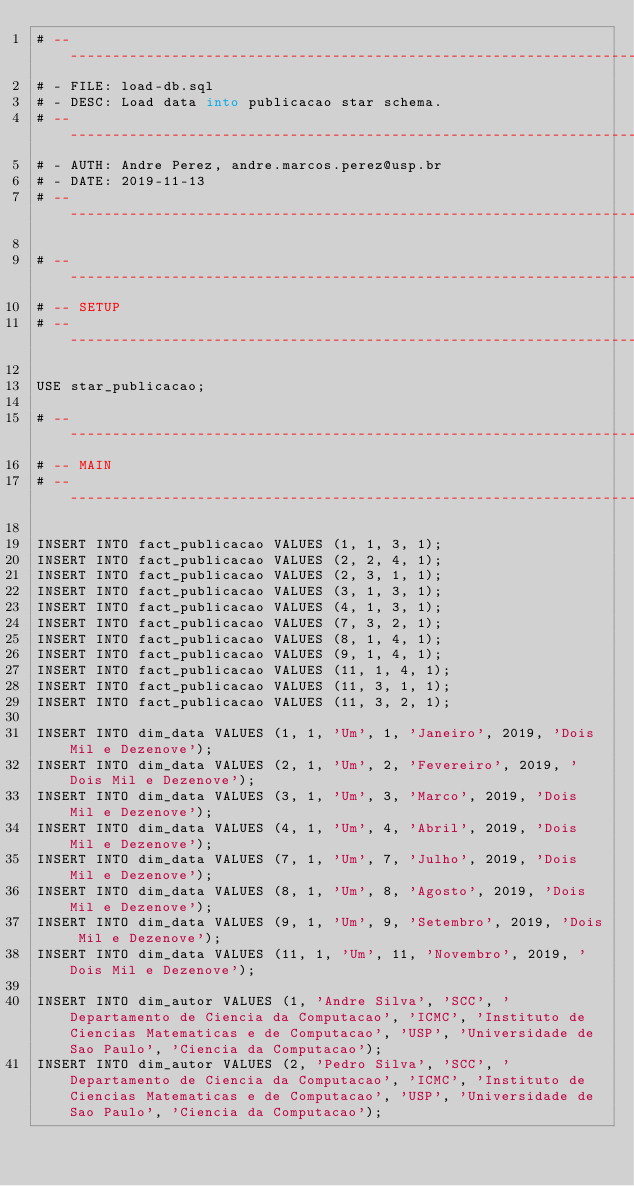Convert code to text. <code><loc_0><loc_0><loc_500><loc_500><_SQL_># ----------------------------------------------------------------------------
# - FILE: load-db.sql
# - DESC: Load data into publicacao star schema.
# ----------------------------------------------------------------------------
# - AUTH: Andre Perez, andre.marcos.perez@usp.br
# - DATE: 2019-11-13
# ----------------------------------------------------------------------------

# ----------------------------------------------------------------------------
# -- SETUP
# ----------------------------------------------------------------------------

USE star_publicacao;

# ----------------------------------------------------------------------------
# -- MAIN
# ----------------------------------------------------------------------------

INSERT INTO fact_publicacao VALUES (1, 1, 3, 1);
INSERT INTO fact_publicacao VALUES (2, 2, 4, 1);
INSERT INTO fact_publicacao VALUES (2, 3, 1, 1);
INSERT INTO fact_publicacao VALUES (3, 1, 3, 1);
INSERT INTO fact_publicacao VALUES (4, 1, 3, 1);
INSERT INTO fact_publicacao VALUES (7, 3, 2, 1);
INSERT INTO fact_publicacao VALUES (8, 1, 4, 1);
INSERT INTO fact_publicacao VALUES (9, 1, 4, 1);
INSERT INTO fact_publicacao VALUES (11, 1, 4, 1);
INSERT INTO fact_publicacao VALUES (11, 3, 1, 1);
INSERT INTO fact_publicacao VALUES (11, 3, 2, 1);

INSERT INTO dim_data VALUES (1, 1, 'Um', 1, 'Janeiro', 2019, 'Dois Mil e Dezenove');
INSERT INTO dim_data VALUES (2, 1, 'Um', 2, 'Fevereiro', 2019, 'Dois Mil e Dezenove');
INSERT INTO dim_data VALUES (3, 1, 'Um', 3, 'Marco', 2019, 'Dois Mil e Dezenove');
INSERT INTO dim_data VALUES (4, 1, 'Um', 4, 'Abril', 2019, 'Dois Mil e Dezenove');
INSERT INTO dim_data VALUES (7, 1, 'Um', 7, 'Julho', 2019, 'Dois Mil e Dezenove');
INSERT INTO dim_data VALUES (8, 1, 'Um', 8, 'Agosto', 2019, 'Dois Mil e Dezenove');
INSERT INTO dim_data VALUES (9, 1, 'Um', 9, 'Setembro', 2019, 'Dois Mil e Dezenove');
INSERT INTO dim_data VALUES (11, 1, 'Um', 11, 'Novembro', 2019, 'Dois Mil e Dezenove');

INSERT INTO dim_autor VALUES (1, 'Andre Silva', 'SCC', 'Departamento de Ciencia da Computacao', 'ICMC', 'Instituto de Ciencias Matematicas e de Computacao', 'USP', 'Universidade de Sao Paulo', 'Ciencia da Computacao');
INSERT INTO dim_autor VALUES (2, 'Pedro Silva', 'SCC', 'Departamento de Ciencia da Computacao', 'ICMC', 'Instituto de Ciencias Matematicas e de Computacao', 'USP', 'Universidade de Sao Paulo', 'Ciencia da Computacao');</code> 